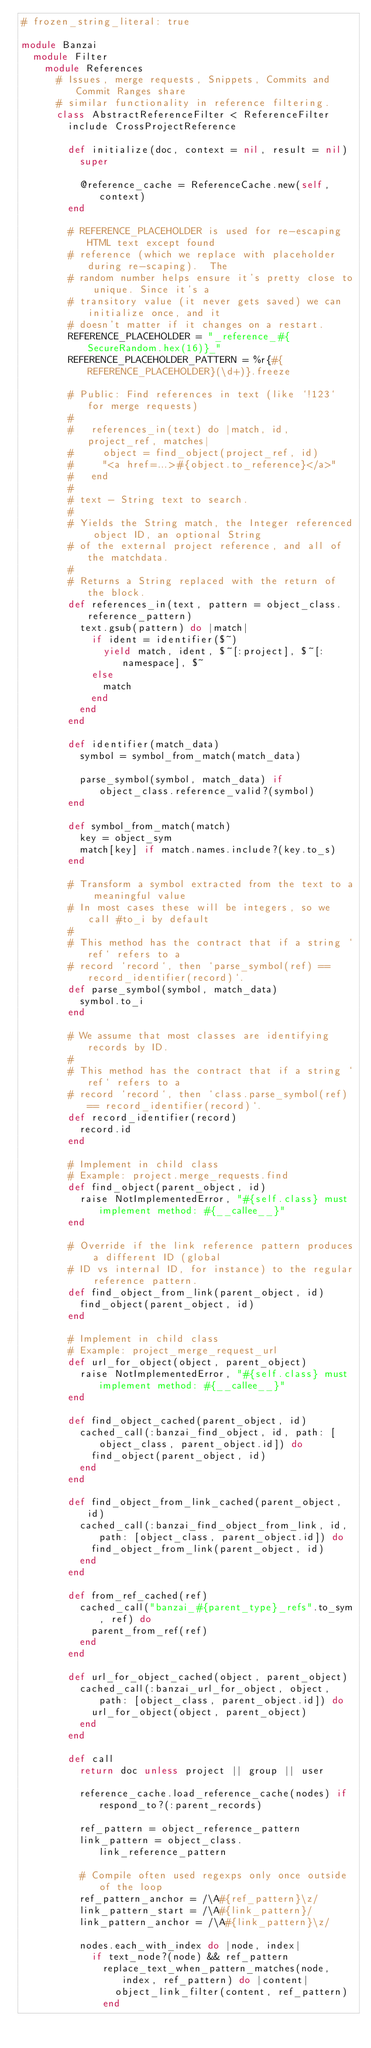<code> <loc_0><loc_0><loc_500><loc_500><_Ruby_># frozen_string_literal: true

module Banzai
  module Filter
    module References
      # Issues, merge requests, Snippets, Commits and Commit Ranges share
      # similar functionality in reference filtering.
      class AbstractReferenceFilter < ReferenceFilter
        include CrossProjectReference

        def initialize(doc, context = nil, result = nil)
          super

          @reference_cache = ReferenceCache.new(self, context)
        end

        # REFERENCE_PLACEHOLDER is used for re-escaping HTML text except found
        # reference (which we replace with placeholder during re-scaping).  The
        # random number helps ensure it's pretty close to unique. Since it's a
        # transitory value (it never gets saved) we can initialize once, and it
        # doesn't matter if it changes on a restart.
        REFERENCE_PLACEHOLDER = "_reference_#{SecureRandom.hex(16)}_"
        REFERENCE_PLACEHOLDER_PATTERN = %r{#{REFERENCE_PLACEHOLDER}(\d+)}.freeze

        # Public: Find references in text (like `!123` for merge requests)
        #
        #   references_in(text) do |match, id, project_ref, matches|
        #     object = find_object(project_ref, id)
        #     "<a href=...>#{object.to_reference}</a>"
        #   end
        #
        # text - String text to search.
        #
        # Yields the String match, the Integer referenced object ID, an optional String
        # of the external project reference, and all of the matchdata.
        #
        # Returns a String replaced with the return of the block.
        def references_in(text, pattern = object_class.reference_pattern)
          text.gsub(pattern) do |match|
            if ident = identifier($~)
              yield match, ident, $~[:project], $~[:namespace], $~
            else
              match
            end
          end
        end

        def identifier(match_data)
          symbol = symbol_from_match(match_data)

          parse_symbol(symbol, match_data) if object_class.reference_valid?(symbol)
        end

        def symbol_from_match(match)
          key = object_sym
          match[key] if match.names.include?(key.to_s)
        end

        # Transform a symbol extracted from the text to a meaningful value
        # In most cases these will be integers, so we call #to_i by default
        #
        # This method has the contract that if a string `ref` refers to a
        # record `record`, then `parse_symbol(ref) == record_identifier(record)`.
        def parse_symbol(symbol, match_data)
          symbol.to_i
        end

        # We assume that most classes are identifying records by ID.
        #
        # This method has the contract that if a string `ref` refers to a
        # record `record`, then `class.parse_symbol(ref) == record_identifier(record)`.
        def record_identifier(record)
          record.id
        end

        # Implement in child class
        # Example: project.merge_requests.find
        def find_object(parent_object, id)
          raise NotImplementedError, "#{self.class} must implement method: #{__callee__}"
        end

        # Override if the link reference pattern produces a different ID (global
        # ID vs internal ID, for instance) to the regular reference pattern.
        def find_object_from_link(parent_object, id)
          find_object(parent_object, id)
        end

        # Implement in child class
        # Example: project_merge_request_url
        def url_for_object(object, parent_object)
          raise NotImplementedError, "#{self.class} must implement method: #{__callee__}"
        end

        def find_object_cached(parent_object, id)
          cached_call(:banzai_find_object, id, path: [object_class, parent_object.id]) do
            find_object(parent_object, id)
          end
        end

        def find_object_from_link_cached(parent_object, id)
          cached_call(:banzai_find_object_from_link, id, path: [object_class, parent_object.id]) do
            find_object_from_link(parent_object, id)
          end
        end

        def from_ref_cached(ref)
          cached_call("banzai_#{parent_type}_refs".to_sym, ref) do
            parent_from_ref(ref)
          end
        end

        def url_for_object_cached(object, parent_object)
          cached_call(:banzai_url_for_object, object, path: [object_class, parent_object.id]) do
            url_for_object(object, parent_object)
          end
        end

        def call
          return doc unless project || group || user

          reference_cache.load_reference_cache(nodes) if respond_to?(:parent_records)

          ref_pattern = object_reference_pattern
          link_pattern = object_class.link_reference_pattern

          # Compile often used regexps only once outside of the loop
          ref_pattern_anchor = /\A#{ref_pattern}\z/
          link_pattern_start = /\A#{link_pattern}/
          link_pattern_anchor = /\A#{link_pattern}\z/

          nodes.each_with_index do |node, index|
            if text_node?(node) && ref_pattern
              replace_text_when_pattern_matches(node, index, ref_pattern) do |content|
                object_link_filter(content, ref_pattern)
              end
</code> 